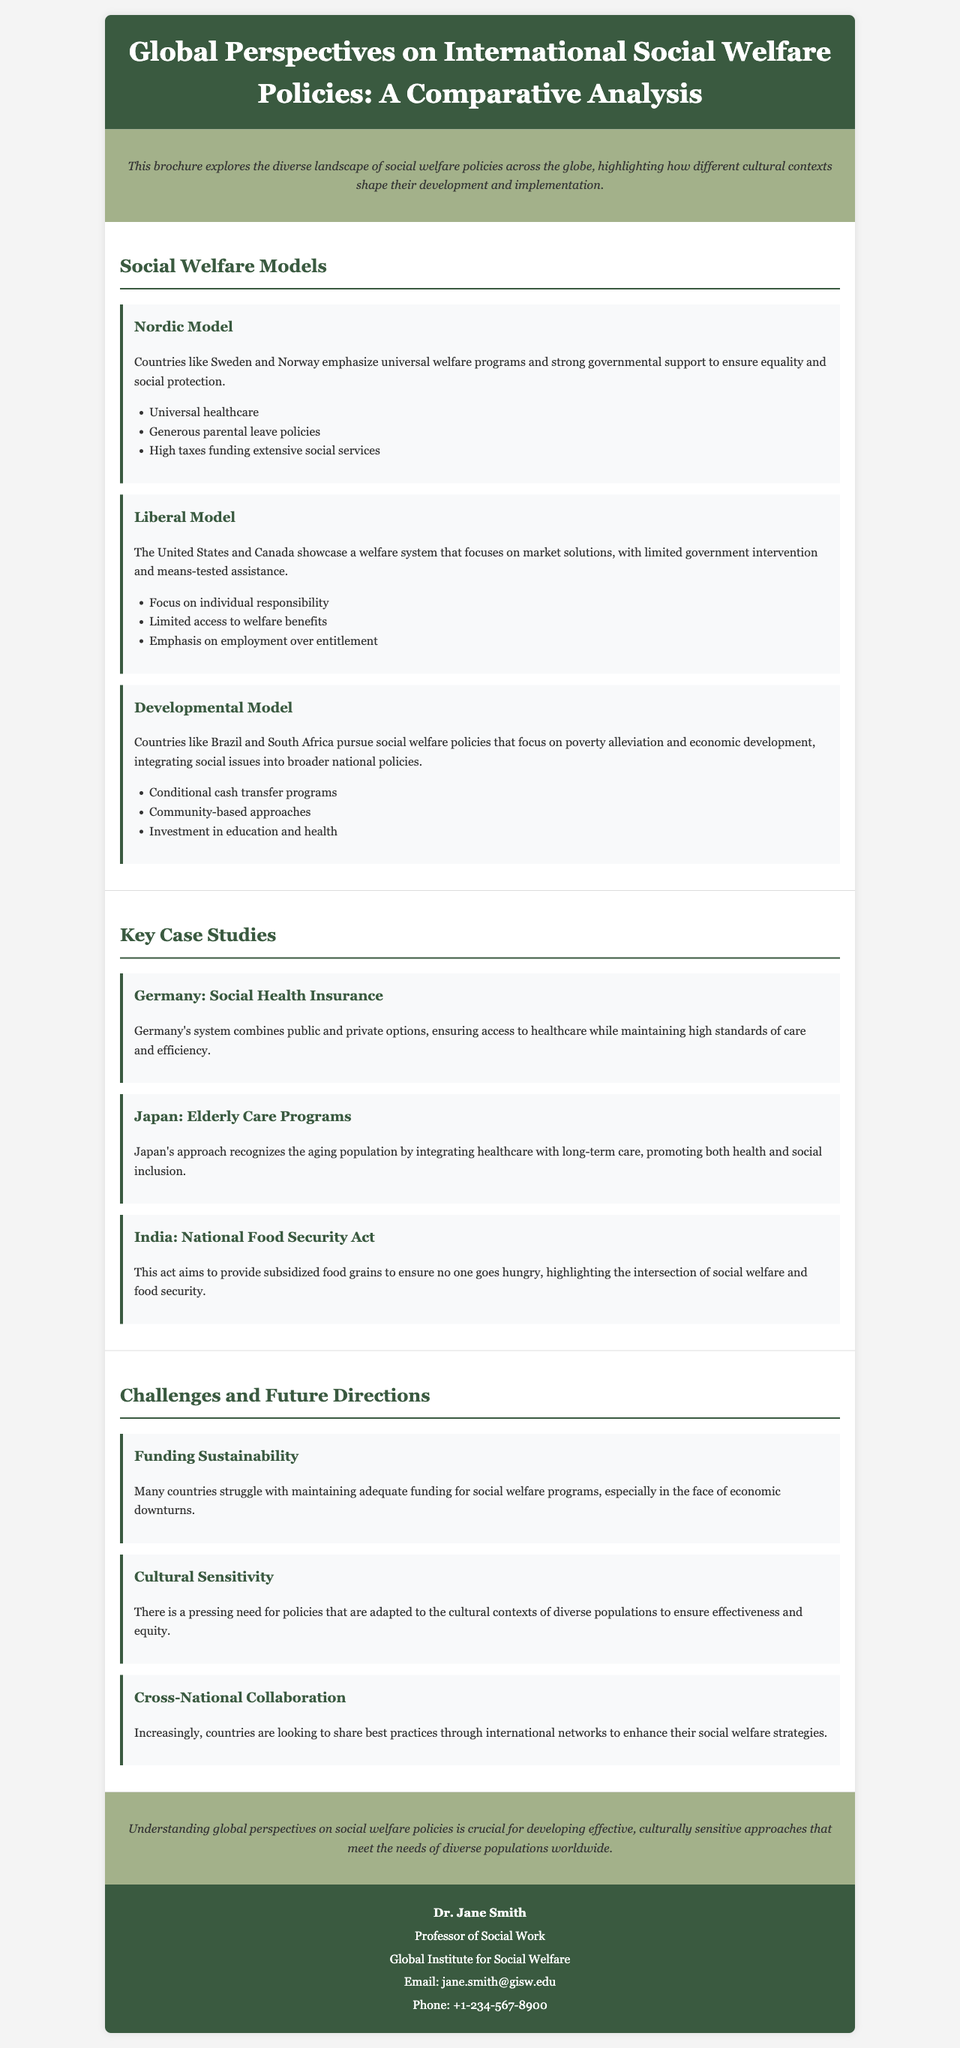what is the title of the brochure? The title is explicitly stated in the header section of the document.
Answer: Global Perspectives on International Social Welfare Policies: A Comparative Analysis what are the three main social welfare models discussed? The models are categorized in the "Social Welfare Models" section of the brochure.
Answer: Nordic Model, Liberal Model, Developmental Model who is the contact person listed in the brochure? The contact information includes the name of a specific individual mentioned at the end of the document.
Answer: Dr. Jane Smith what key case study is associated with Germany? The document highlights a specific case study regarding Germany in the "Key Case Studies" section.
Answer: Social Health Insurance what challenge related to social welfare is emphasized in the brochure? The "Challenges and Future Directions" section lists specific challenges, including this one.
Answer: Funding Sustainability how many case studies are presented in the brochure? The total number of case studies can be counted in the respective section of the document.
Answer: Three which country is mentioned in relation to the National Food Security Act? This specific act is highlighted as a key case study within the brochure.
Answer: India what is the main focus of the Nordic Model? The description of the Nordic Model provides insights into its key principles.
Answer: Universal welfare programs what does the brochure suggest is necessary for effective social welfare policies? The conclusion summarizes the overarching themes discussed throughout the document.
Answer: Cultural sensitivity 